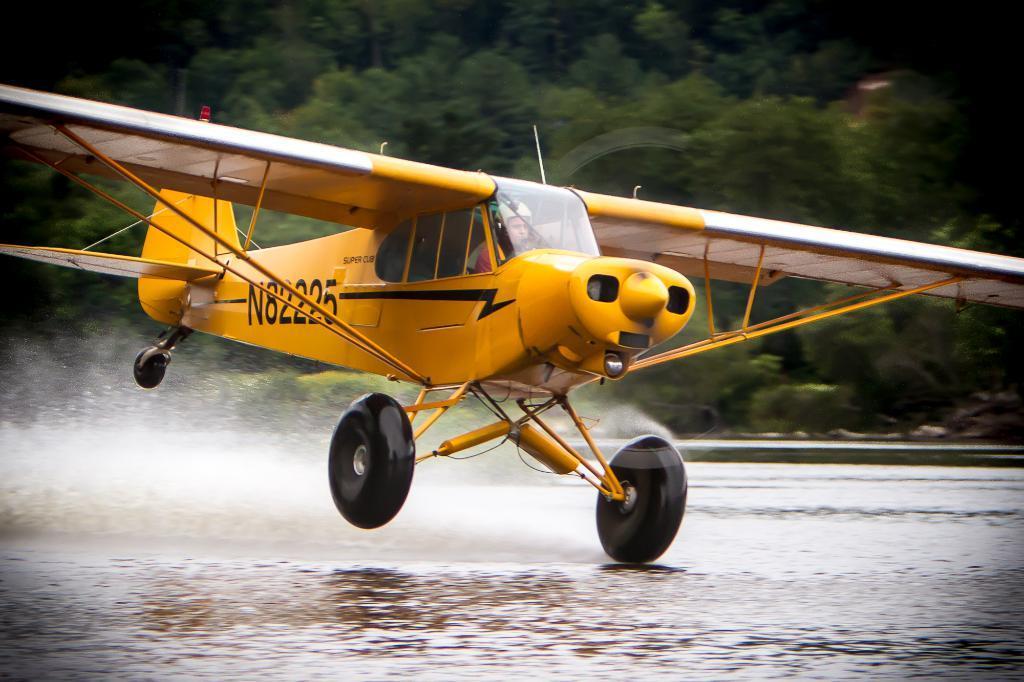How would you summarize this image in a sentence or two? In this image we can see a yellow color chopper. Back ground so many trees are there and on land water is present. 